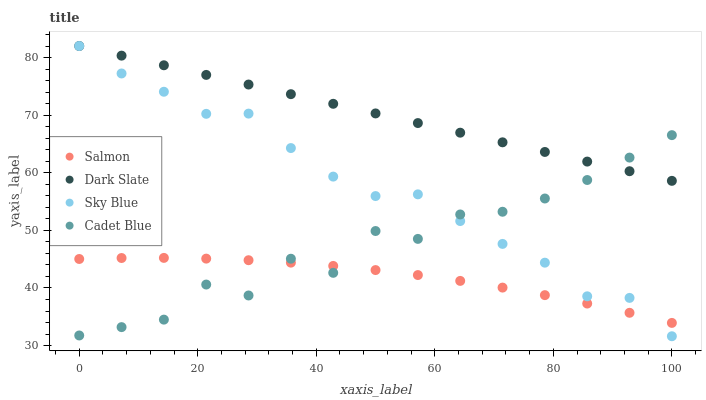Does Salmon have the minimum area under the curve?
Answer yes or no. Yes. Does Dark Slate have the maximum area under the curve?
Answer yes or no. Yes. Does Cadet Blue have the minimum area under the curve?
Answer yes or no. No. Does Cadet Blue have the maximum area under the curve?
Answer yes or no. No. Is Dark Slate the smoothest?
Answer yes or no. Yes. Is Cadet Blue the roughest?
Answer yes or no. Yes. Is Salmon the smoothest?
Answer yes or no. No. Is Salmon the roughest?
Answer yes or no. No. Does Sky Blue have the lowest value?
Answer yes or no. Yes. Does Cadet Blue have the lowest value?
Answer yes or no. No. Does Sky Blue have the highest value?
Answer yes or no. Yes. Does Cadet Blue have the highest value?
Answer yes or no. No. Is Salmon less than Dark Slate?
Answer yes or no. Yes. Is Dark Slate greater than Salmon?
Answer yes or no. Yes. Does Sky Blue intersect Dark Slate?
Answer yes or no. Yes. Is Sky Blue less than Dark Slate?
Answer yes or no. No. Is Sky Blue greater than Dark Slate?
Answer yes or no. No. Does Salmon intersect Dark Slate?
Answer yes or no. No. 